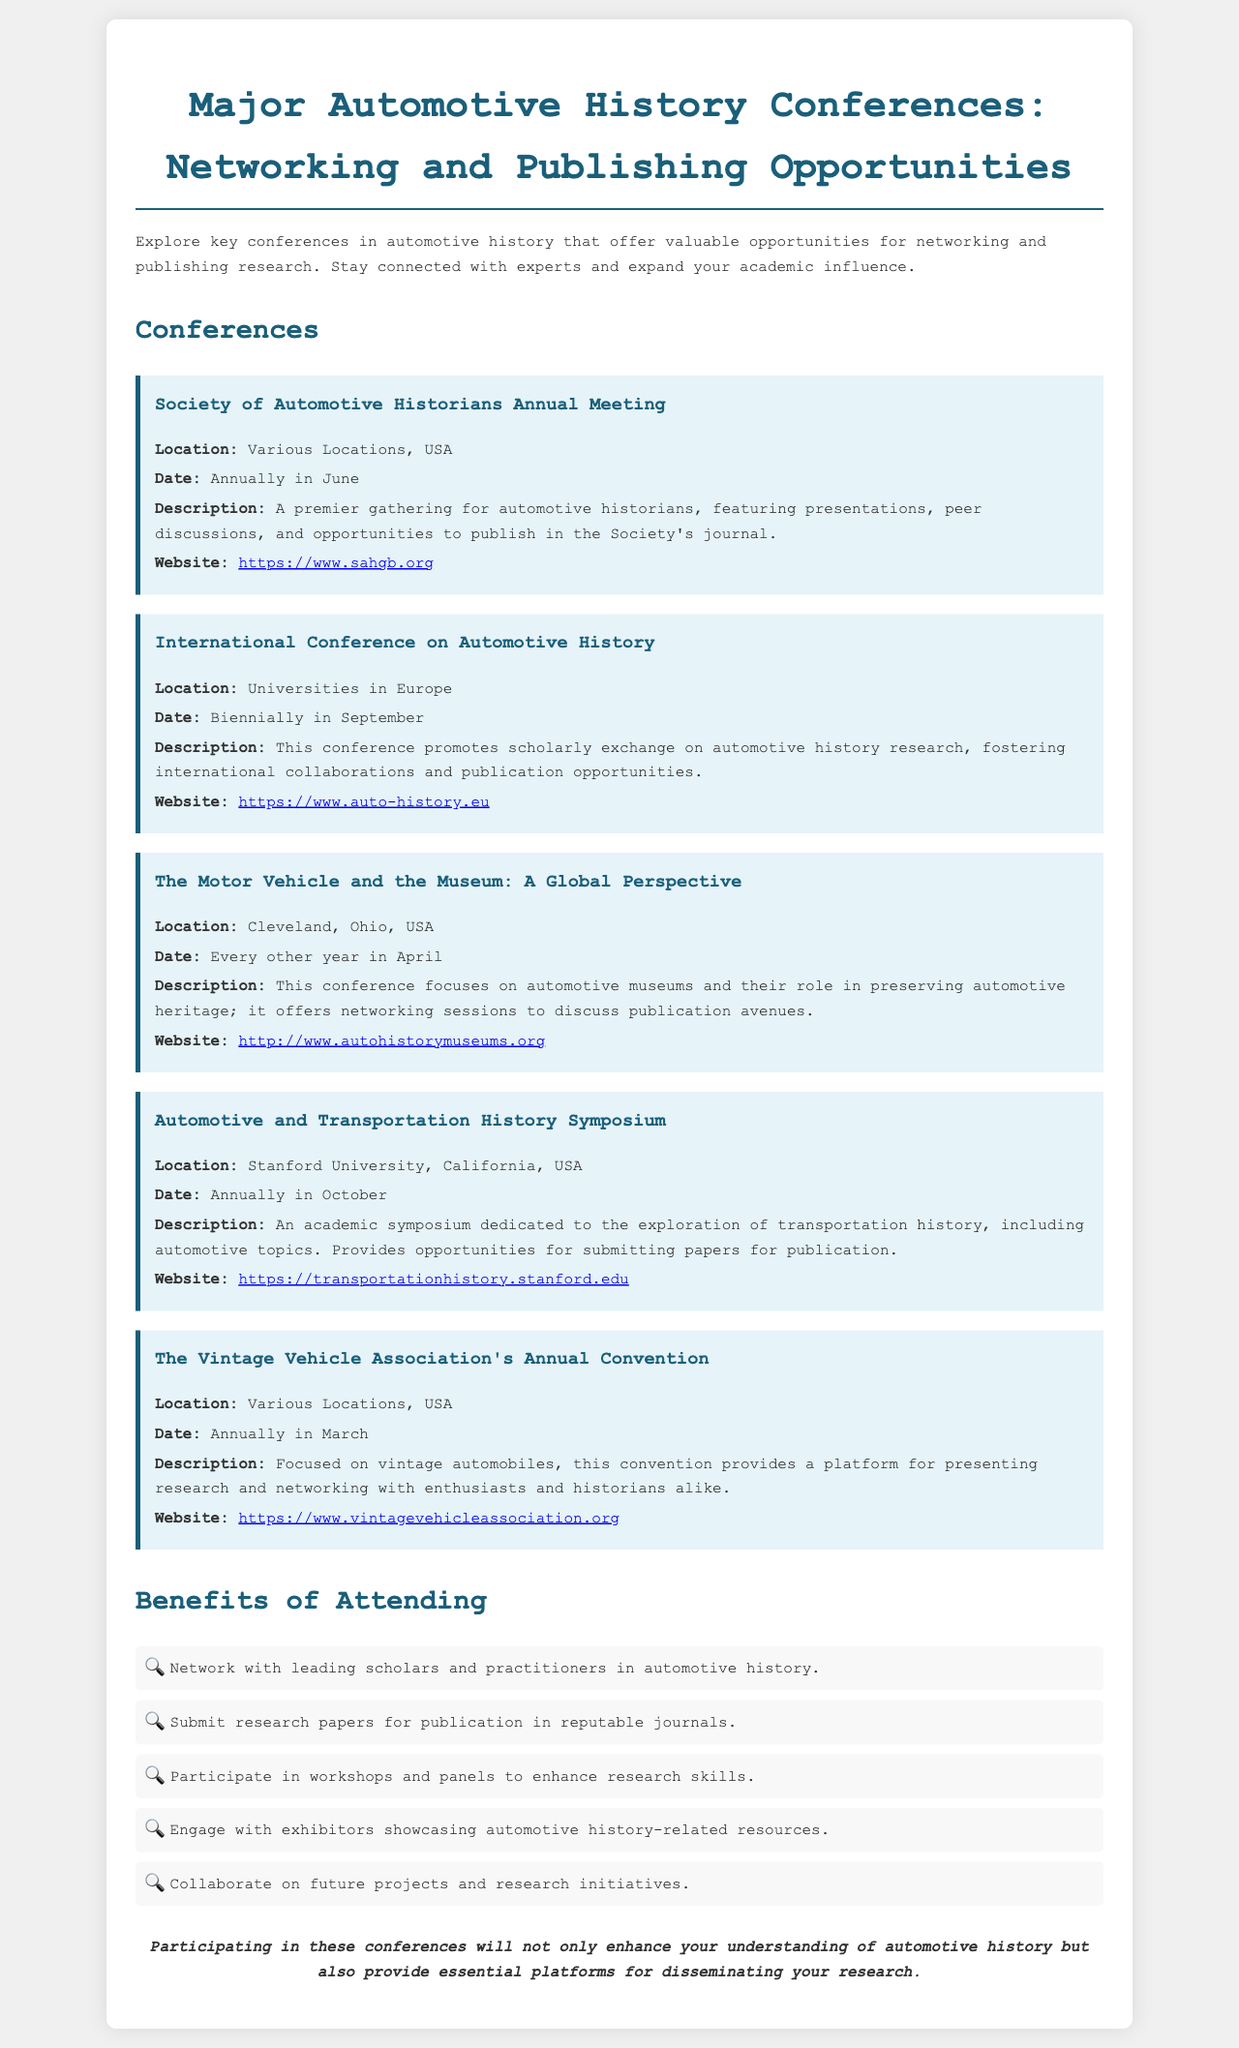What is the location of the Society of Automotive Historians Annual Meeting? The document states that the location is "Various Locations, USA."
Answer: Various Locations, USA When does the International Conference on Automotive History occur? It occurs biennially in September, as noted in the document.
Answer: Biennially in September What is one major focus of The Motor Vehicle and the Museum conference? The conference focuses on automotive museums and their role in preserving automotive heritage.
Answer: Automotive museums Which conference is held at Stanford University? The document specifies that the "Automotive and Transportation History Symposium" is held at Stanford University.
Answer: Automotive and Transportation History Symposium How often does The Vintage Vehicle Association's Annual Convention take place? The document indicates that it is held annually in March.
Answer: Annually in March What benefit does attending these conferences offer regarding research papers? The document mentions that attendees can submit research papers for publication in reputable journals.
Answer: Submit research papers for publication What is a key activity participants can engage in at these conferences? Participants can network with leading scholars and practitioners in automotive history.
Answer: Network with leading scholars What type of document is this? The document is a brochure that outlines major automotive history conferences and their opportunities.
Answer: Brochure 